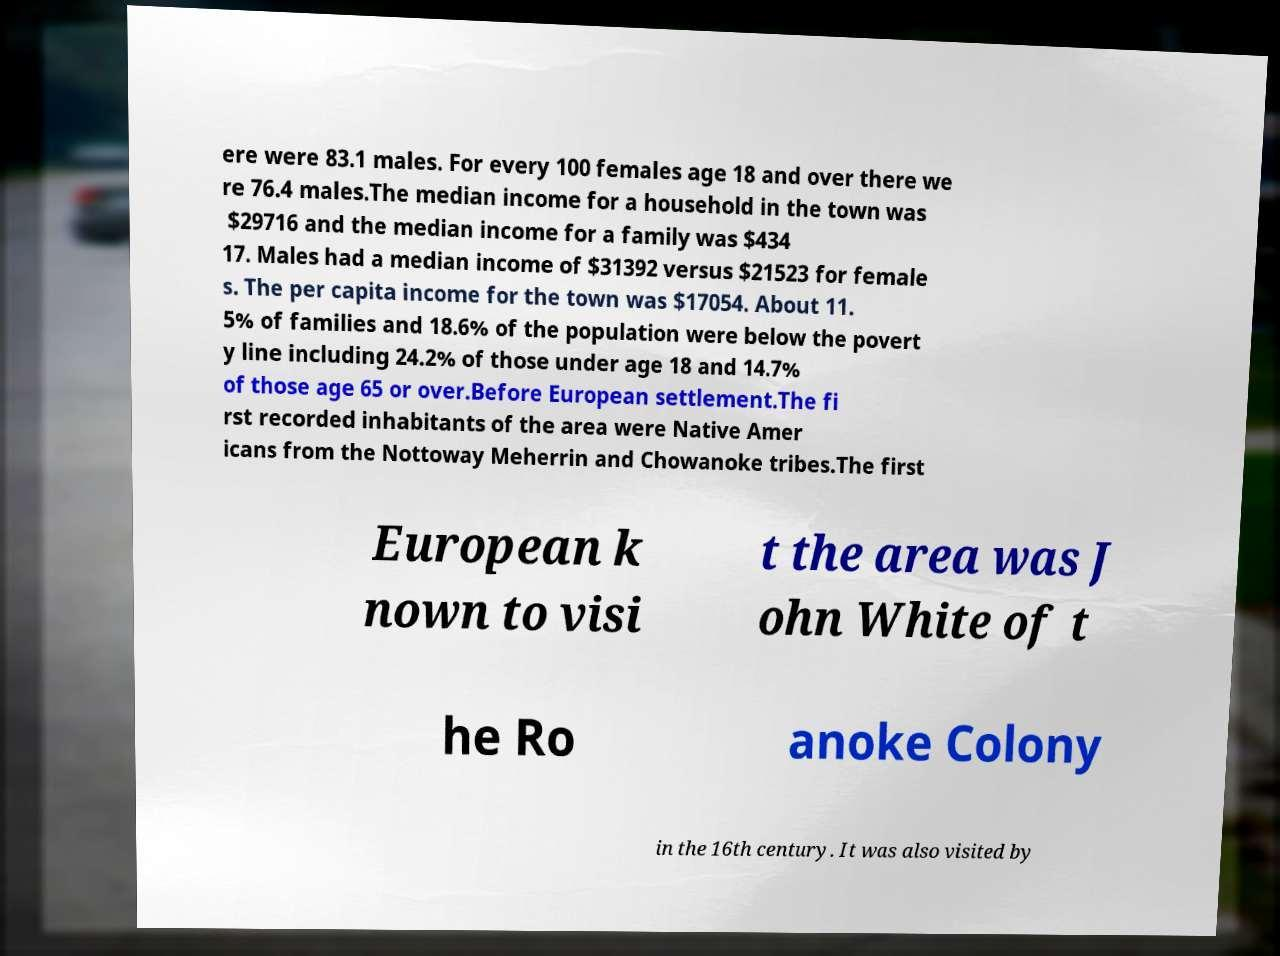What messages or text are displayed in this image? I need them in a readable, typed format. ere were 83.1 males. For every 100 females age 18 and over there we re 76.4 males.The median income for a household in the town was $29716 and the median income for a family was $434 17. Males had a median income of $31392 versus $21523 for female s. The per capita income for the town was $17054. About 11. 5% of families and 18.6% of the population were below the povert y line including 24.2% of those under age 18 and 14.7% of those age 65 or over.Before European settlement.The fi rst recorded inhabitants of the area were Native Amer icans from the Nottoway Meherrin and Chowanoke tribes.The first European k nown to visi t the area was J ohn White of t he Ro anoke Colony in the 16th century. It was also visited by 